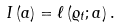Convert formula to latex. <formula><loc_0><loc_0><loc_500><loc_500>I \left ( a \right ) = \ell \left ( \varrho _ { t } ; a \right ) .</formula> 